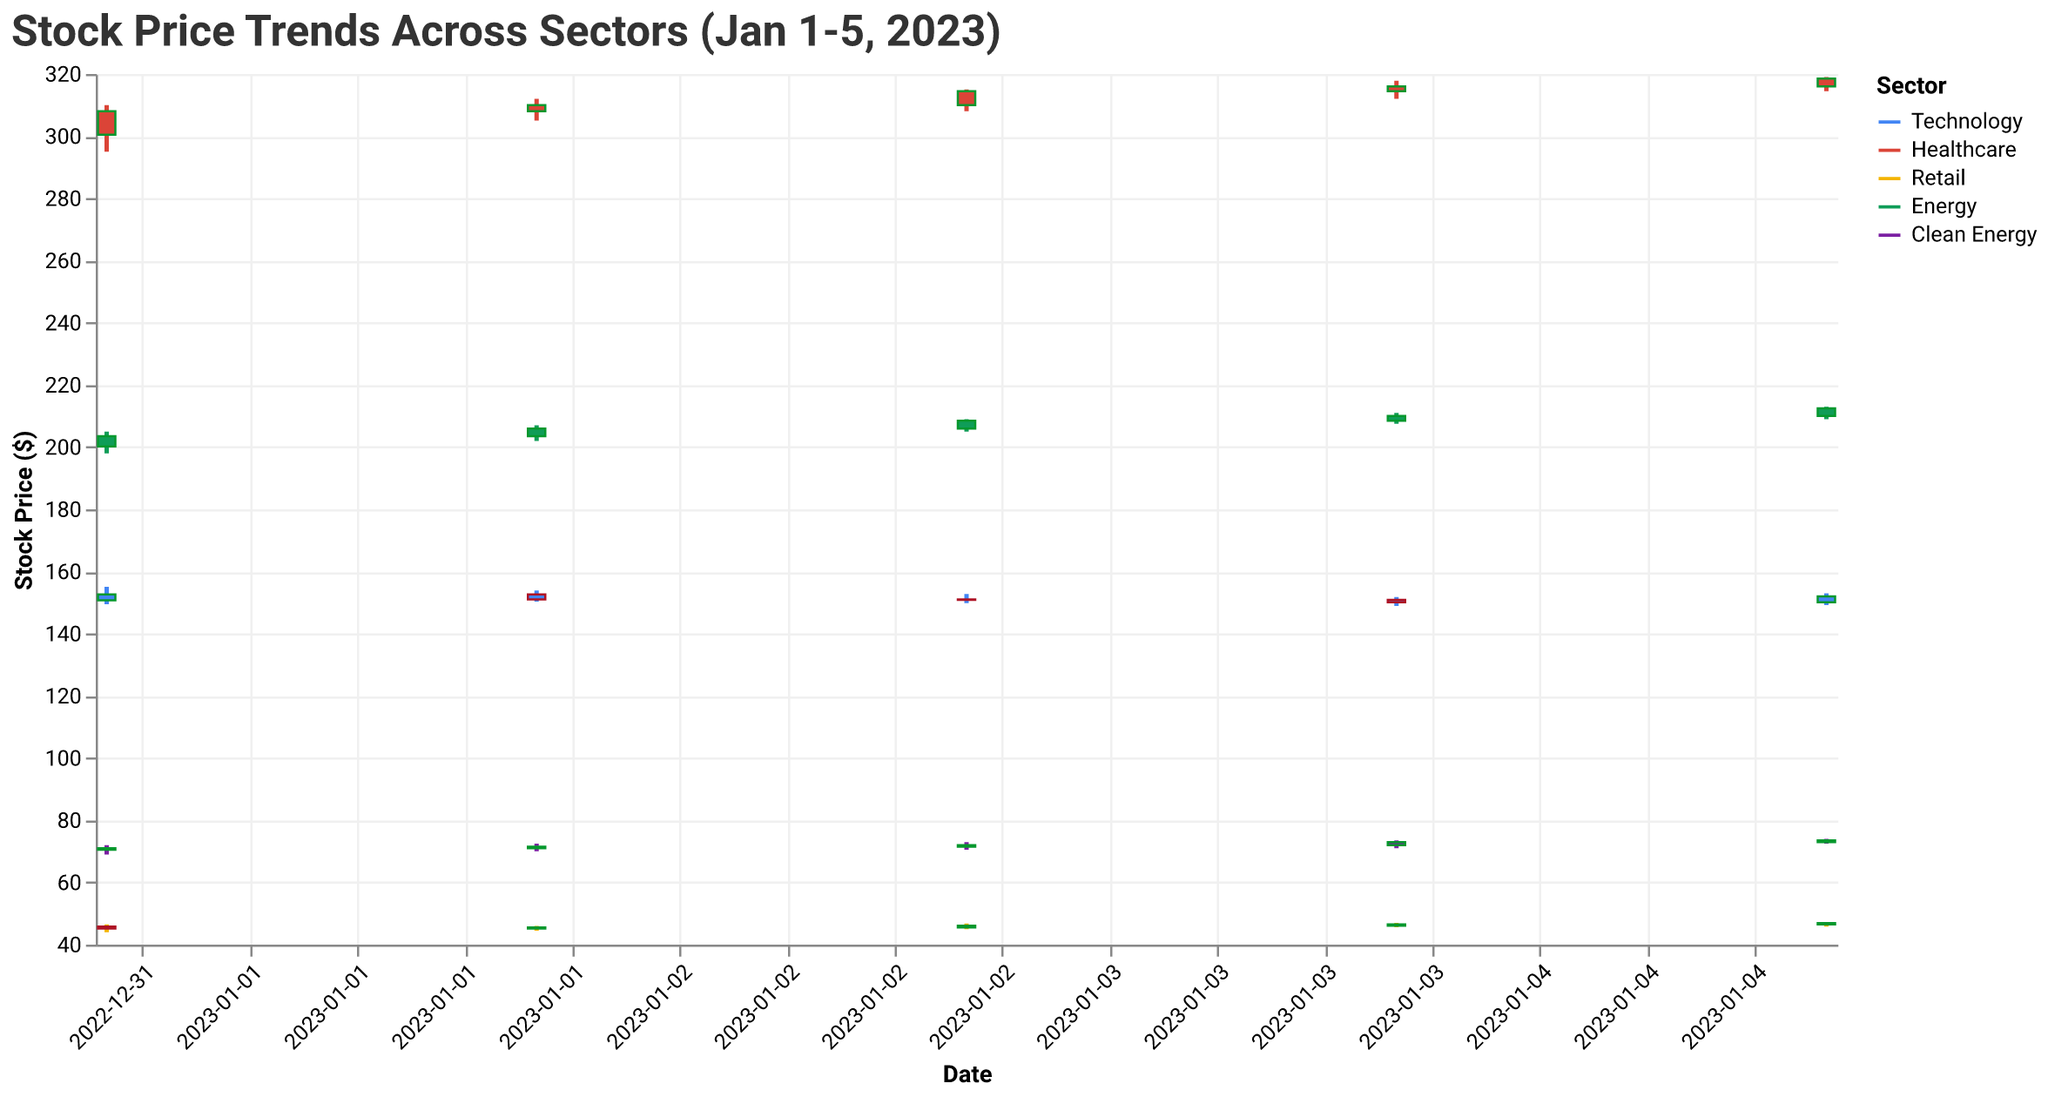What's the overall trend in stock prices for TechCorp Inc from Jan 1 to Jan 5, 2023? Looking at the candle bodies for TechCorp Inc, the opening and closing prices do not show a clear upward or downward trend. After opening at 150.75 on Jan 1 and closing at 152.60, the stock fluctuates, ending at 152.00 on Jan 5.
Answer: No clear trend Which sector has consistently increasing stock prices from Jan 1 to Jan 5, 2023? By comparing the closing prices each day for each sector, HealthCare Innovations in the Healthcare sector shows consistently increasing stock prices from 308.00 to 318.50.
Answer: Healthcare On which date did RetailRevival Corp have the highest trading volume? Checking the dates and their corresponding volumes for RetailRevival Corp, the highest volume of 860,000 occurred on Jan 5.
Answer: Jan 5 Comparing Jan 1 to Jan 5, which stock had the greatest price increase? By calculating the difference between the closing prices on Jan 1 and Jan 5 for each company, HealthCare Innovations had the highest increase (318.50 - 308.00 = 10.50).
Answer: HealthCare Innovations What is the highest stock price observed for EnergyFuture LLC during Jan 1 to Jan 5, 2023? Scanning all the high prices for EnergyFuture LLC, the highest was 213.00 on Jan 5.
Answer: 213.00 Which sector showed the least volatility in terms of stock price range from Jan 1 to Jan 5, 2023? Volatility can be examined by comparing the difference between the highest and lowest prices for each sector. Retail sector had the least range difference (47.20 - 44.00 = 3.20).
Answer: Retail On which day did TechCorp Inc have the biggest difference between its high and low prices? By identifying the largest difference between high and low per day for TechCorp Inc, the biggest range was on Jan 1 with a difference of (155.10 - 149.50 = 5.60).
Answer: Jan 1 What's the average increase in closing prices from Jan 1 to Jan 5 for GreenInvestments Ltd? The daily increases in closing prices for GreenInvestments Ltd are: 0.50, 0.50, 1.00, 0.50, summing to a total increase of 2.5. Dividing by 4 to get the average, the result is 0.625.
Answer: 0.625 